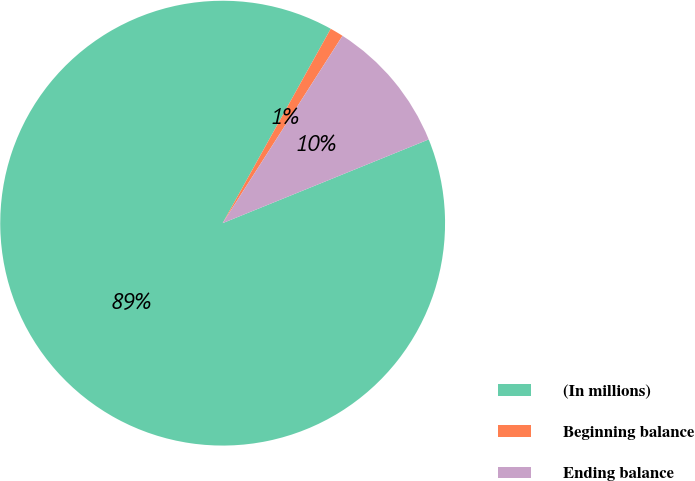<chart> <loc_0><loc_0><loc_500><loc_500><pie_chart><fcel>(In millions)<fcel>Beginning balance<fcel>Ending balance<nl><fcel>89.22%<fcel>0.98%<fcel>9.8%<nl></chart> 